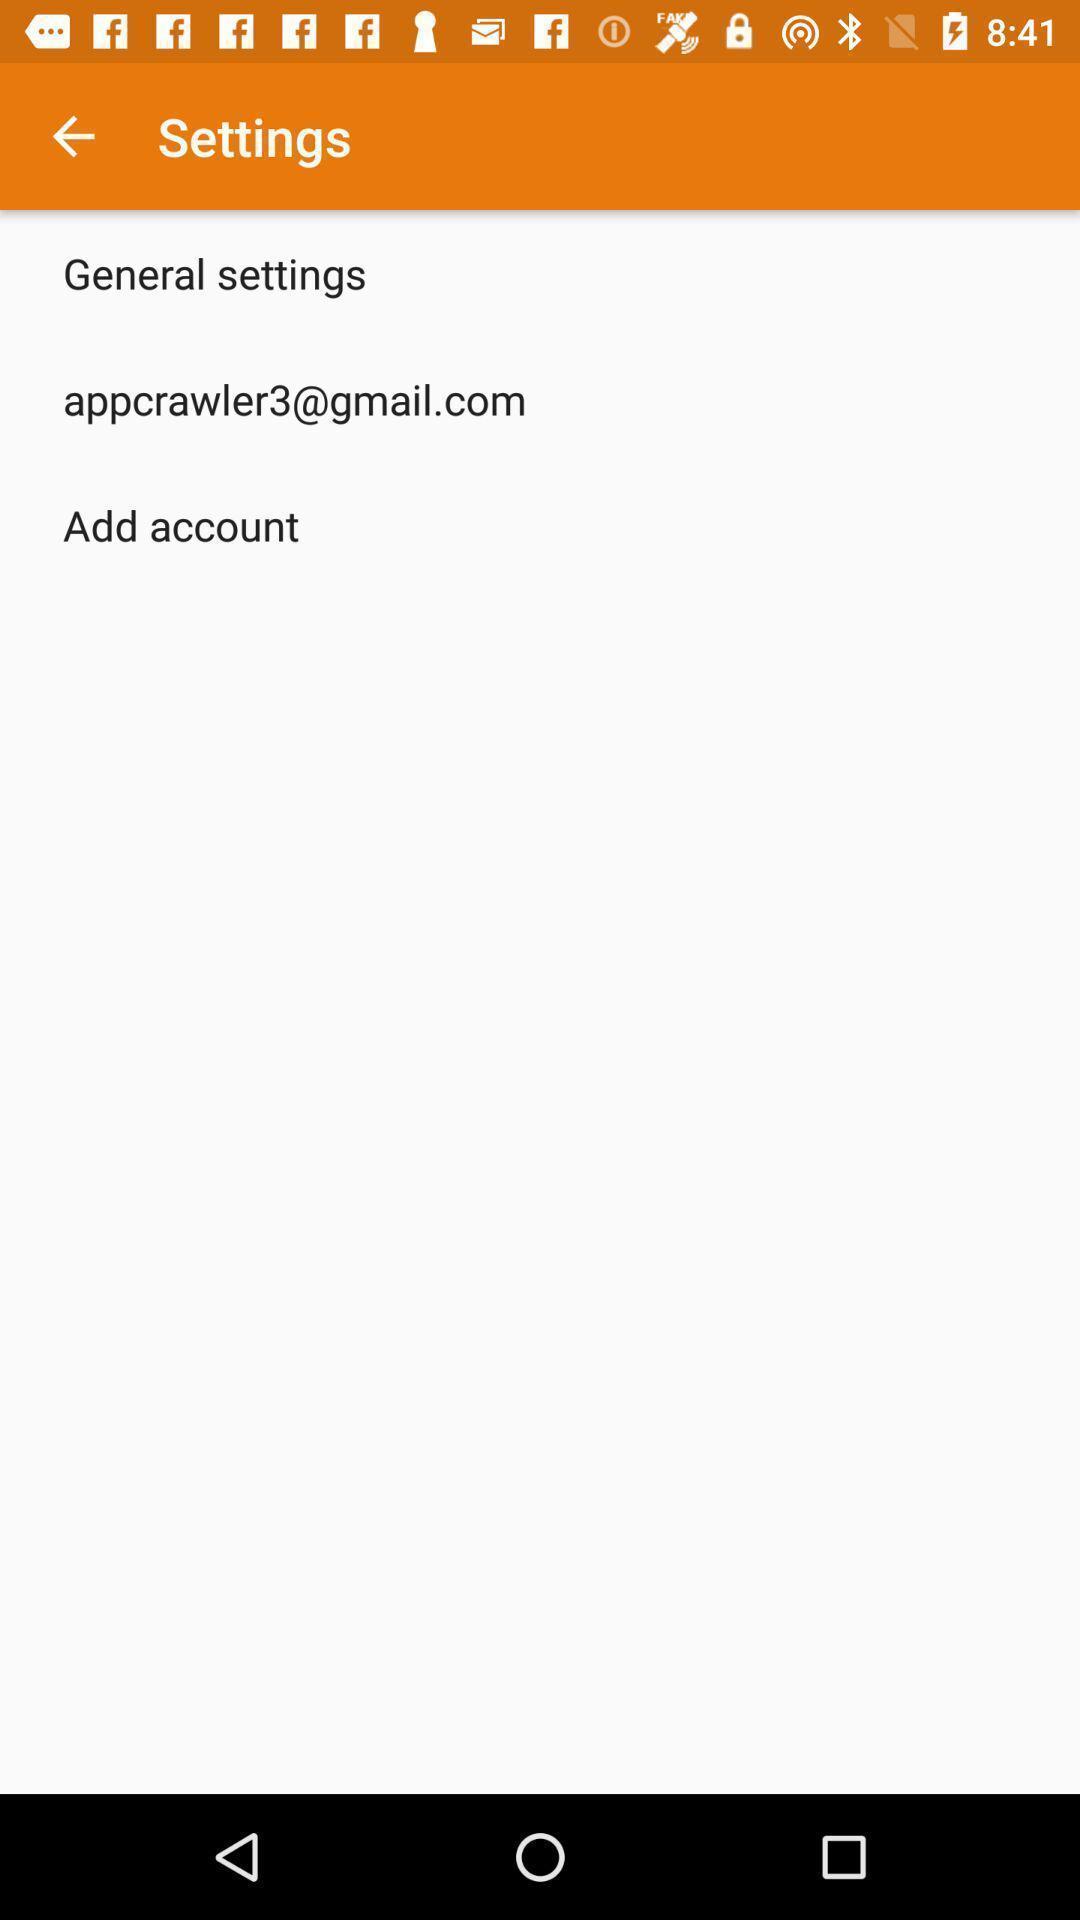Tell me what you see in this picture. Settings tab with some options in mobile. 